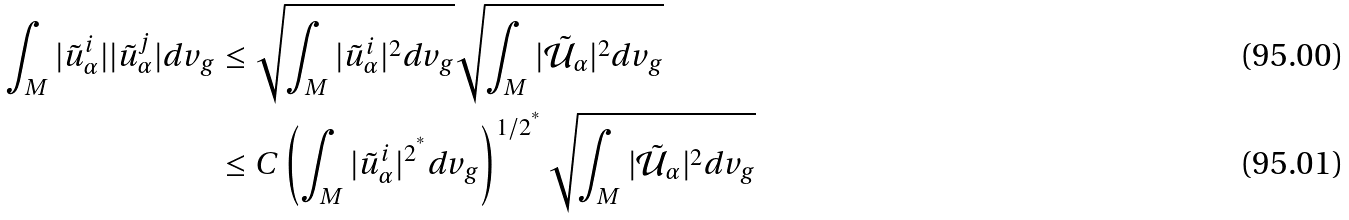Convert formula to latex. <formula><loc_0><loc_0><loc_500><loc_500>\int _ { M } | \tilde { u } _ { \alpha } ^ { i } | | \tilde { u } _ { \alpha } ^ { j } | d v _ { g } & \leq \sqrt { \int _ { M } | \tilde { u } _ { \alpha } ^ { i } | ^ { 2 } d v _ { g } } \sqrt { \int _ { M } | \tilde { \mathcal { U } } _ { \alpha } | ^ { 2 } d v _ { g } } \\ & \leq C \left ( \int _ { M } | \tilde { u } _ { \alpha } ^ { i } | ^ { 2 ^ { ^ { * } } } d v _ { g } \right ) ^ { 1 / 2 ^ { ^ { * } } } \sqrt { \int _ { M } | \tilde { \mathcal { U } } _ { \alpha } | ^ { 2 } d v _ { g } }</formula> 